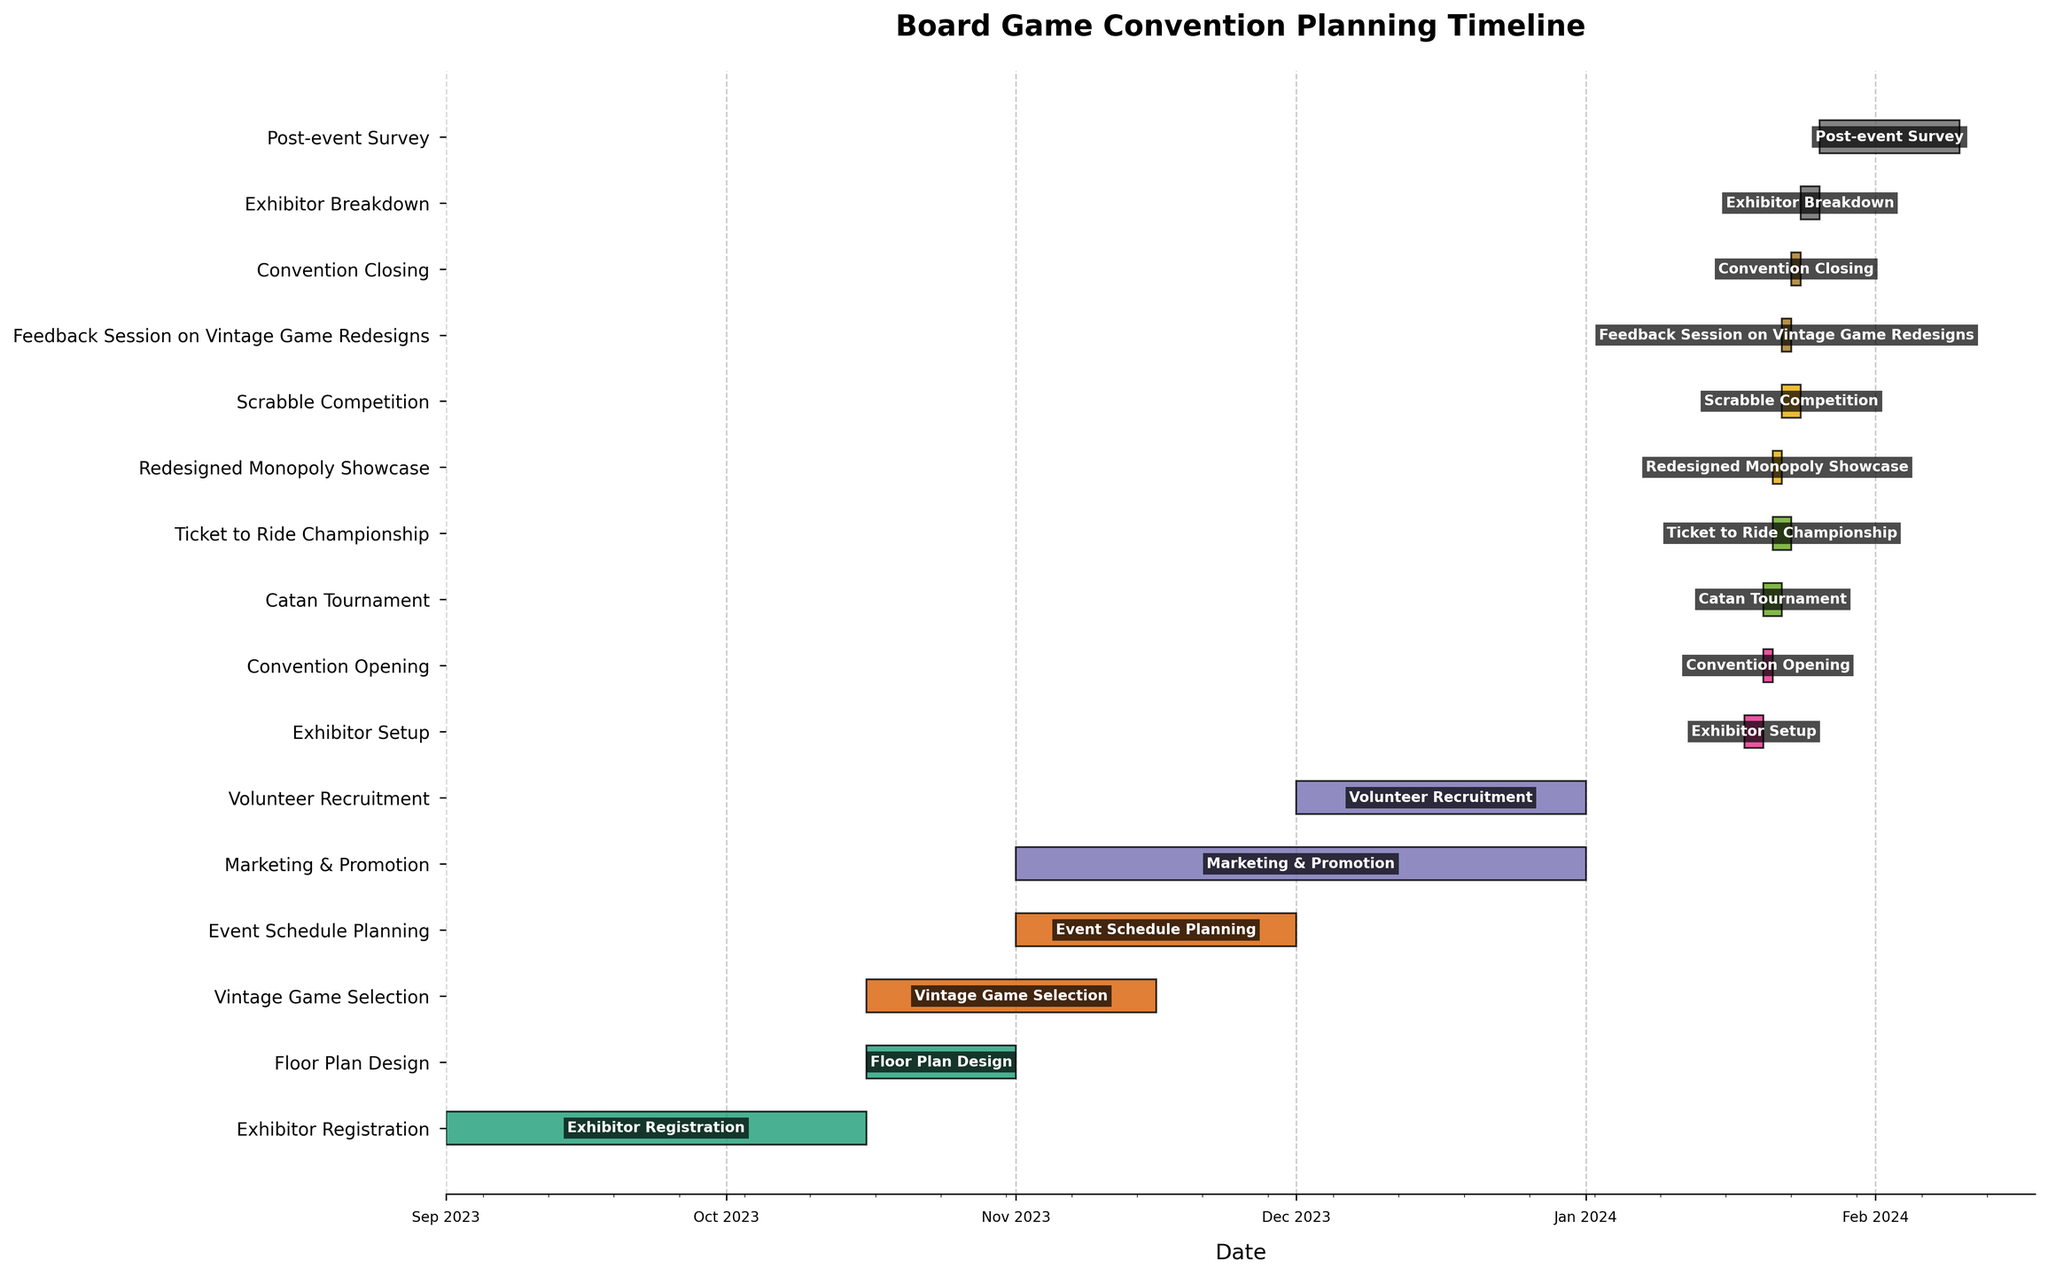What is the title of the Gantt Chart? The title is typically placed at the top of the figure. It is "Board Game Convention Planning Timeline".
Answer: Board Game Convention Planning Timeline What are the first and last tasks listed on the chart? The first task is placed at the top of the chart and the last task is at the bottom. The first task is "Exhibitor Registration" and the last task is "Post-event Survey".
Answer: Exhibitor Registration and Post-event Survey How long is the Marketing & Promotion phase? Locate the "Marketing & Promotion" bar and calculate the time from its start to its end, which is from 2023-11-01 to 2023-12-31. This duration is 61 days.
Answer: 61 days During which month does the Exhibitor Setup take place? Find the "Exhibitor Setup" and look at its position on the date axis. It takes place entirely within January 2024.
Answer: January 2024 Which task overlaps with the Catan Tournament? Locate the "Catan Tournament" bar and see which other bars overlap temporally. "Redesigned Monopoly Showcase" and "Ticket to Ride Championship" overlap with it on 2024-01-21.
Answer: Redesigned Monopoly Showcase, Ticket to Ride Championship What is the combined duration of the Convention Opening, Catan Tournament, Ticket to Ride Championship, and Convention Closing? Sum the durations of the mentioned tasks: Convention Opening (1 day), Catan Tournament (2 days), Ticket to Ride Championship (2 days), and Convention Closing (1 day). The combined duration is 1 + 2 + 2 + 1 = 6 days.
Answer: 6 days Which task has the shortest duration, and what is its length? Locate the task with the shortest bar. "Convention Opening" and "Feedback Session on Vintage Game Redesigns" both last for 1 day.
Answer: Convention Opening and Feedback Session on Vintage Game Redesigns, 1 day Which two tasks have the same start date but different end dates in November? Identify tasks starting on the same date in November. "Event Schedule Planning" and "Marketing & Promotion" both start on 2023-11-01, but their end dates differ.
Answer: Event Schedule Planning and Marketing & Promotion What is the difference in days between the end of Exhibitor Registration and the start of Floor Plan Design? Calculate the difference between the end date of "Exhibitor Registration" (2023-10-15) and the start date of "Floor Plan Design" (2023-10-16). It's the next day, so the difference is 1 day.
Answer: 1 day Which phases overlap with Floor Plan Design? Identify the timeline for "Floor Plan Design" and see which other tasks share any overlapping time. "Vintage Game Selection" overlaps from 2023-10-16 to 2023-10-31.
Answer: Vintage Game Selection 